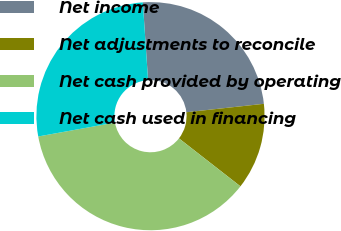<chart> <loc_0><loc_0><loc_500><loc_500><pie_chart><fcel>Net income<fcel>Net adjustments to reconcile<fcel>Net cash provided by operating<fcel>Net cash used in financing<nl><fcel>24.34%<fcel>12.27%<fcel>36.61%<fcel>26.78%<nl></chart> 